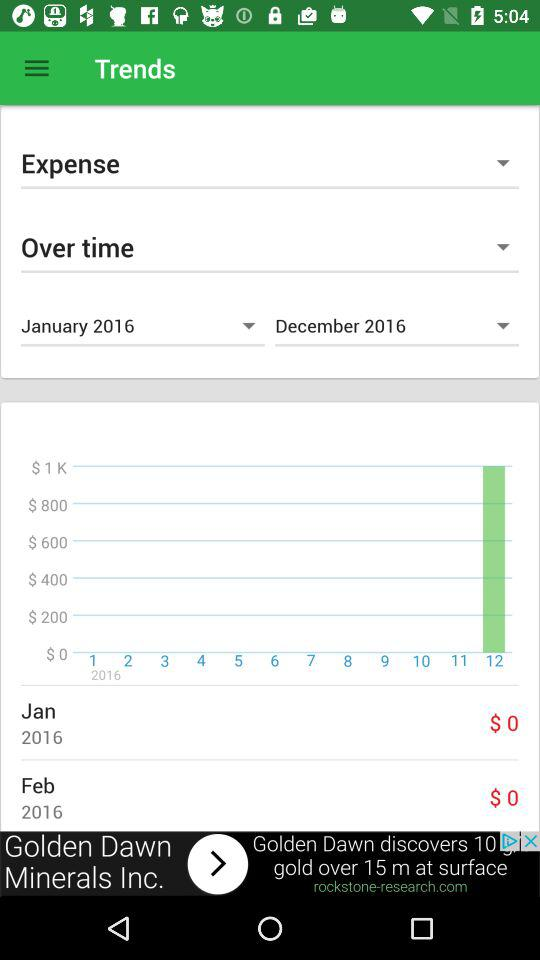What is the expense in November 2023?
When the provided information is insufficient, respond with <no answer>. <no answer> 